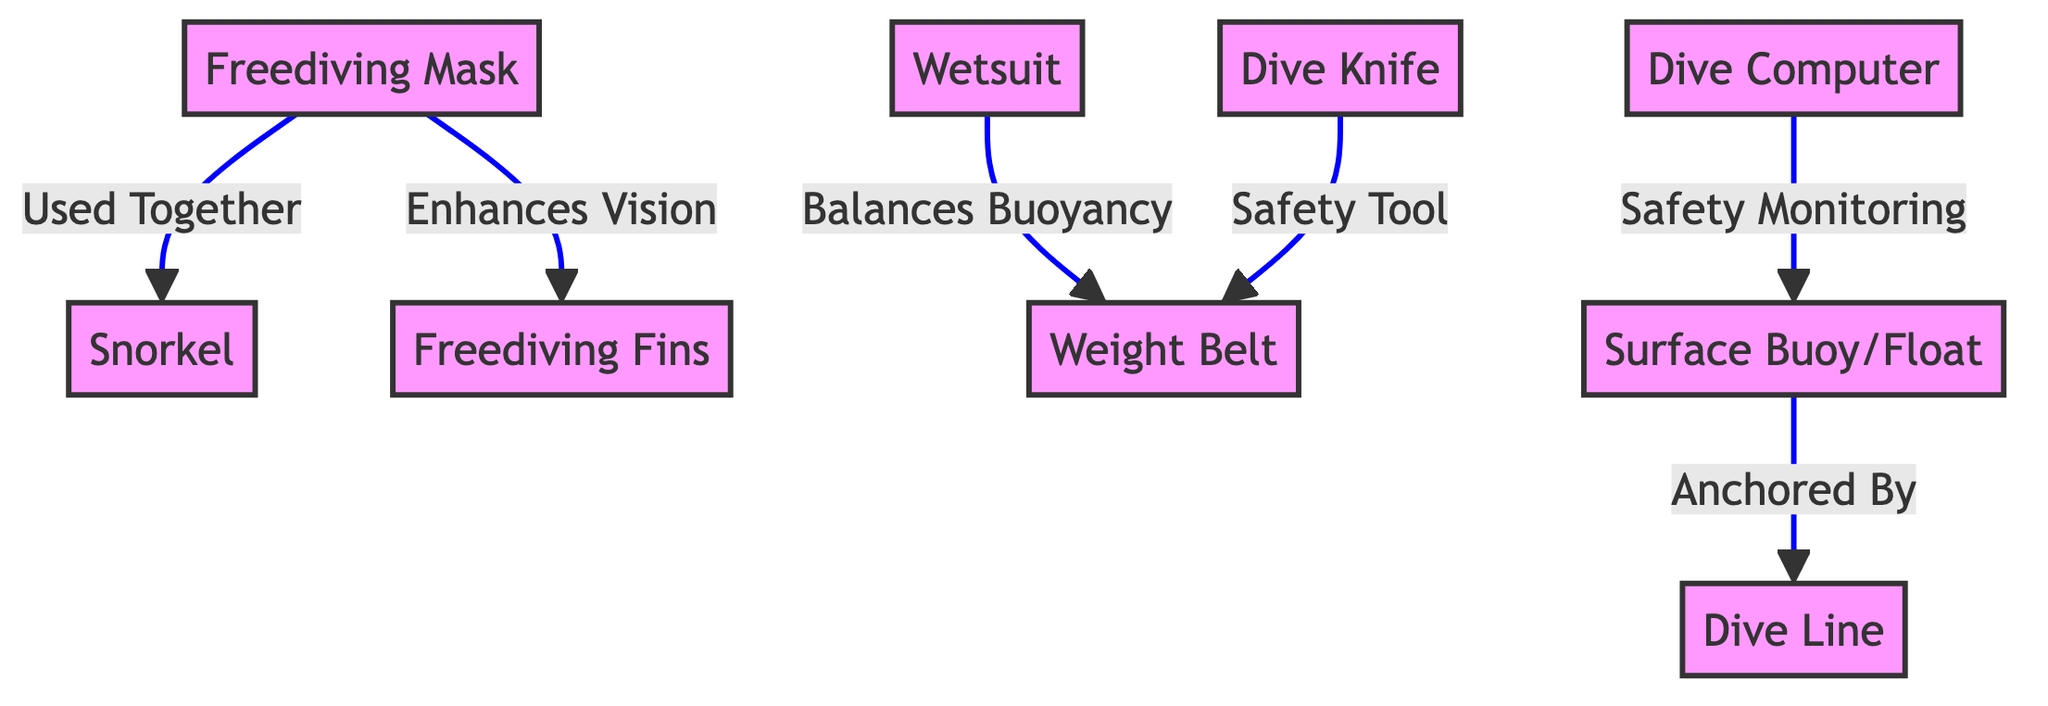What are the nodes in this diagram? The diagram includes the following nodes: Freediving Mask, Snorkel, Wetsuit, Freediving Fins, Weight Belt, Dive Computer, Dive Knife, Surface Buoy/Float, and Dive Line.
Answer: 9 How many edges are there in the diagram? The diagram has connections between nodes, specifically linking pairs with relationships. Upon counting, there are six edges shown, representing relationships.
Answer: 6 Which gear is used together with the Freediving Mask? The diagram shows an edge labeled "Used Together" connecting the Freediving Mask to the Snorkel, indicating they are used together during freediving.
Answer: Snorkel What does the Wetsuit do in relation to the Weight Belt? The diagram illustrates a relationship labeled "Balances Buoyancy" between the Wetsuit and the Weight Belt, indicating that the Wetsuit helps maintain buoyancy when using the Weight Belt.
Answer: Balances Buoyancy Which equipment is monitored for safety purposes? The Dive Computer is linked with the Surface Buoy/Float by an edge labeled "Safety Monitoring," indicating that the Dive Computer monitors safety aspects during freediving.
Answer: Dive Computer How does the Freediving Mask enhance the freediving experience? The Freediving Mask is connected to Freediving Fins by "Enhances Vision," suggesting that using the mask improves visibility underwater, which positively affects the freediving experience.
Answer: Enhances Vision What gear is the Dive Knife associated with in terms of safety? The Dive Knife is connected to the Weight Belt through an edge labeled "Safety Tool," indicating that the Dive Knife is often associated with the Weight Belt to enhance safety while diving.
Answer: Weight Belt What is the relationship between the Surface Buoy/Float and Dive Line? The diagram shows that the Surface Buoy/Float is "Anchored By" the Dive Line, indicating how the float is secured in place, which is essential in freediving for safety and organization.
Answer: Anchored By What two pieces of equipment work together to help you see better? The Freediving Mask and Freediving Fins are linked by "Enhances Vision," which implies that both items assist in improving visibility while underwater during freediving.
Answer: Freediving Mask, Freediving Fins 